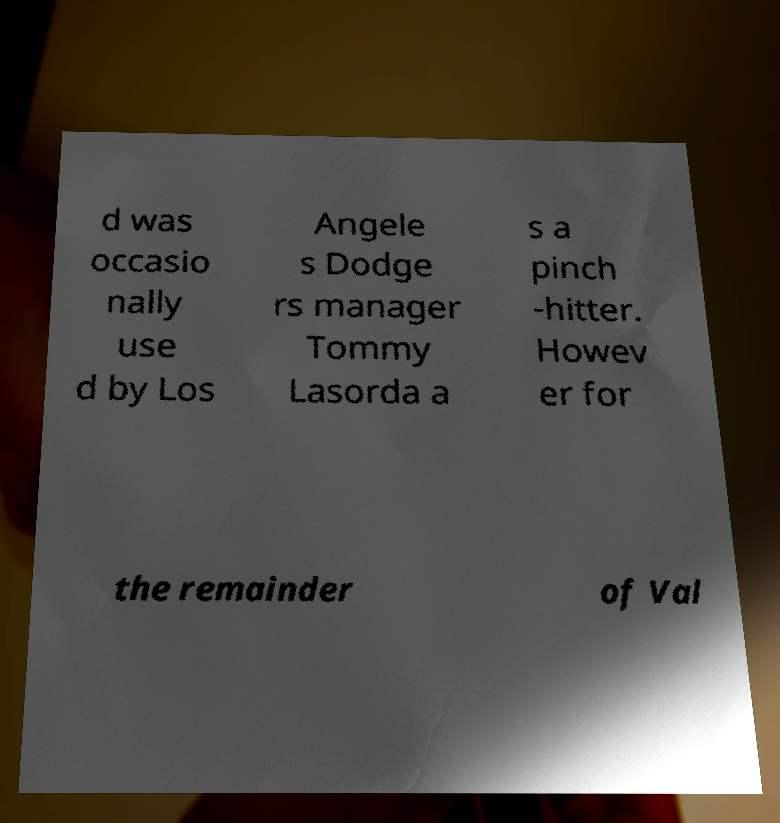I need the written content from this picture converted into text. Can you do that? d was occasio nally use d by Los Angele s Dodge rs manager Tommy Lasorda a s a pinch -hitter. Howev er for the remainder of Val 